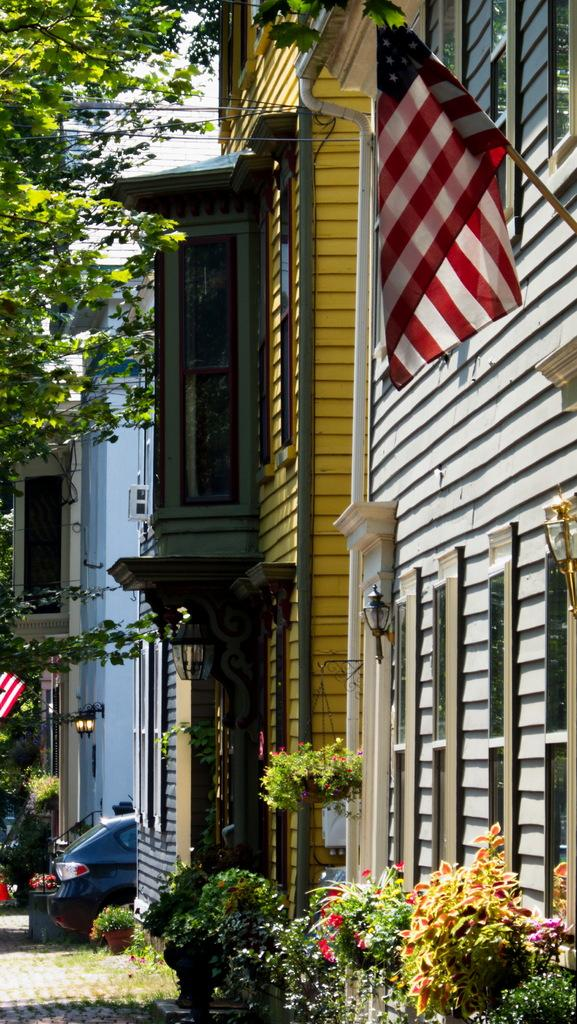What is located in the center of the image? There are buildings in the center of the image. What type of vegetation can be seen in the image? There are branches with leaves and plants in the image. What lighting elements are present in the image? There are lamps in the image. Can you identify any mode of transportation in the image? Yes, there is at least one vehicle in the image. Are there any other objects visible in the image? Yes, there are a few other objects in the image. What type of locket is hanging from the branches in the image? There is no locket present in the image; it features buildings, branches with leaves, plants, lamps, a vehicle, and other objects. Can you describe the flavor of the jam on the vehicle in the image? There is no jam present in the image; it features a vehicle and other objects. 